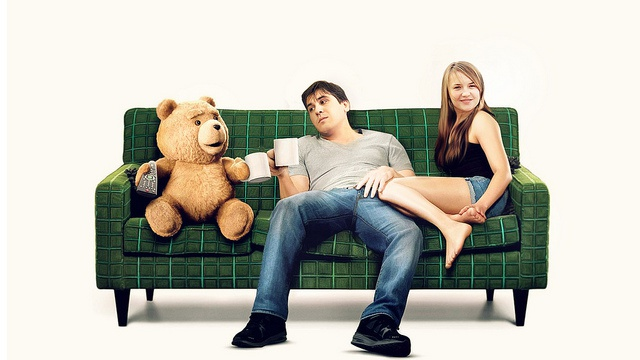Describe the objects in this image and their specific colors. I can see people in white, black, lightgray, darkgray, and tan tones, couch in white, black, and darkgreen tones, couch in white, black, and darkgreen tones, people in white, tan, black, and beige tones, and teddy bear in white, tan, black, and brown tones in this image. 